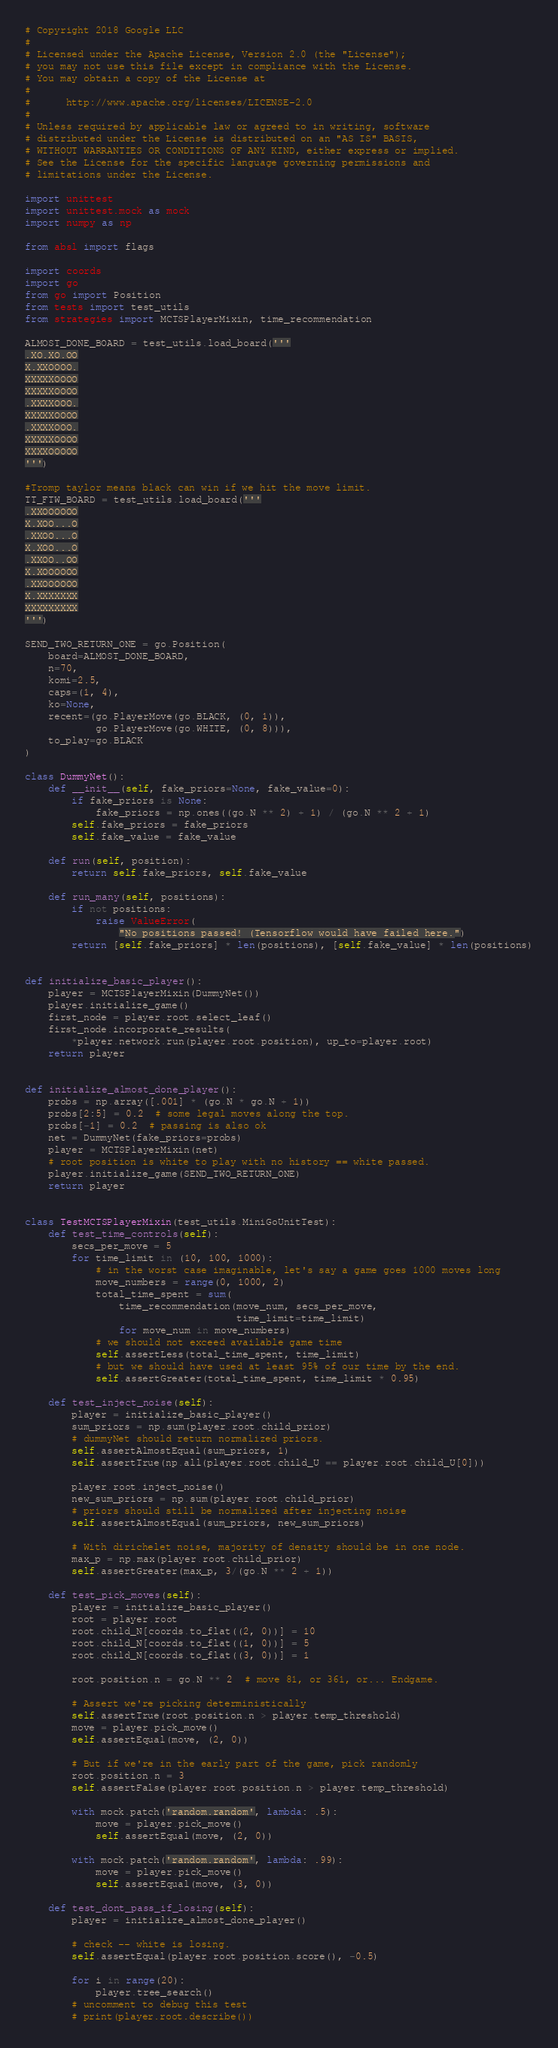Convert code to text. <code><loc_0><loc_0><loc_500><loc_500><_Python_># Copyright 2018 Google LLC
#
# Licensed under the Apache License, Version 2.0 (the "License");
# you may not use this file except in compliance with the License.
# You may obtain a copy of the License at
#
#      http://www.apache.org/licenses/LICENSE-2.0
#
# Unless required by applicable law or agreed to in writing, software
# distributed under the License is distributed on an "AS IS" BASIS,
# WITHOUT WARRANTIES OR CONDITIONS OF ANY KIND, either express or implied.
# See the License for the specific language governing permissions and
# limitations under the License.

import unittest
import unittest.mock as mock
import numpy as np

from absl import flags

import coords
import go
from go import Position
from tests import test_utils
from strategies import MCTSPlayerMixin, time_recommendation

ALMOST_DONE_BOARD = test_utils.load_board('''
.XO.XO.OO
X.XXOOOO.
XXXXXOOOO
XXXXXOOOO
.XXXXOOO.
XXXXXOOOO
.XXXXOOO.
XXXXXOOOO
XXXXOOOOO
''')

#Tromp taylor means black can win if we hit the move limit.
TT_FTW_BOARD = test_utils.load_board('''
.XXOOOOOO
X.XOO...O
.XXOO...O
X.XOO...O
.XXOO..OO
X.XOOOOOO
.XXOOOOOO
X.XXXXXXX
XXXXXXXXX
''')

SEND_TWO_RETURN_ONE = go.Position(
    board=ALMOST_DONE_BOARD,
    n=70,
    komi=2.5,
    caps=(1, 4),
    ko=None,
    recent=(go.PlayerMove(go.BLACK, (0, 1)),
            go.PlayerMove(go.WHITE, (0, 8))),
    to_play=go.BLACK
)

class DummyNet():
    def __init__(self, fake_priors=None, fake_value=0):
        if fake_priors is None:
            fake_priors = np.ones((go.N ** 2) + 1) / (go.N ** 2 + 1)
        self.fake_priors = fake_priors
        self.fake_value = fake_value

    def run(self, position):
        return self.fake_priors, self.fake_value

    def run_many(self, positions):
        if not positions:
            raise ValueError(
                "No positions passed! (Tensorflow would have failed here.")
        return [self.fake_priors] * len(positions), [self.fake_value] * len(positions)


def initialize_basic_player():
    player = MCTSPlayerMixin(DummyNet())
    player.initialize_game()
    first_node = player.root.select_leaf()
    first_node.incorporate_results(
        *player.network.run(player.root.position), up_to=player.root)
    return player


def initialize_almost_done_player():
    probs = np.array([.001] * (go.N * go.N + 1))
    probs[2:5] = 0.2  # some legal moves along the top.
    probs[-1] = 0.2  # passing is also ok
    net = DummyNet(fake_priors=probs)
    player = MCTSPlayerMixin(net)
    # root position is white to play with no history == white passed.
    player.initialize_game(SEND_TWO_RETURN_ONE)
    return player


class TestMCTSPlayerMixin(test_utils.MiniGoUnitTest):
    def test_time_controls(self):
        secs_per_move = 5
        for time_limit in (10, 100, 1000):
            # in the worst case imaginable, let's say a game goes 1000 moves long
            move_numbers = range(0, 1000, 2)
            total_time_spent = sum(
                time_recommendation(move_num, secs_per_move,
                                    time_limit=time_limit)
                for move_num in move_numbers)
            # we should not exceed available game time
            self.assertLess(total_time_spent, time_limit)
            # but we should have used at least 95% of our time by the end.
            self.assertGreater(total_time_spent, time_limit * 0.95)

    def test_inject_noise(self):
        player = initialize_basic_player()
        sum_priors = np.sum(player.root.child_prior)
        # dummyNet should return normalized priors.
        self.assertAlmostEqual(sum_priors, 1)
        self.assertTrue(np.all(player.root.child_U == player.root.child_U[0]))

        player.root.inject_noise()
        new_sum_priors = np.sum(player.root.child_prior)
        # priors should still be normalized after injecting noise
        self.assertAlmostEqual(sum_priors, new_sum_priors)

        # With dirichelet noise, majority of density should be in one node.
        max_p = np.max(player.root.child_prior)
        self.assertGreater(max_p, 3/(go.N ** 2 + 1))

    def test_pick_moves(self):
        player = initialize_basic_player()
        root = player.root
        root.child_N[coords.to_flat((2, 0))] = 10
        root.child_N[coords.to_flat((1, 0))] = 5
        root.child_N[coords.to_flat((3, 0))] = 1

        root.position.n = go.N ** 2  # move 81, or 361, or... Endgame.

        # Assert we're picking deterministically
        self.assertTrue(root.position.n > player.temp_threshold)
        move = player.pick_move()
        self.assertEqual(move, (2, 0))

        # But if we're in the early part of the game, pick randomly
        root.position.n = 3
        self.assertFalse(player.root.position.n > player.temp_threshold)

        with mock.patch('random.random', lambda: .5):
            move = player.pick_move()
            self.assertEqual(move, (2, 0))

        with mock.patch('random.random', lambda: .99):
            move = player.pick_move()
            self.assertEqual(move, (3, 0))

    def test_dont_pass_if_losing(self):
        player = initialize_almost_done_player()

        # check -- white is losing.
        self.assertEqual(player.root.position.score(), -0.5)

        for i in range(20):
            player.tree_search()
        # uncomment to debug this test
        # print(player.root.describe())
</code> 